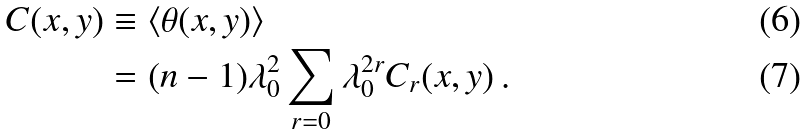<formula> <loc_0><loc_0><loc_500><loc_500>C ( x , y ) & \equiv \langle \theta ( x , y ) \rangle \, \\ & = ( n - 1 ) \lambda _ { 0 } ^ { 2 } \sum _ { r = 0 } \lambda _ { 0 } ^ { 2 r } C _ { r } ( x , y ) \, .</formula> 